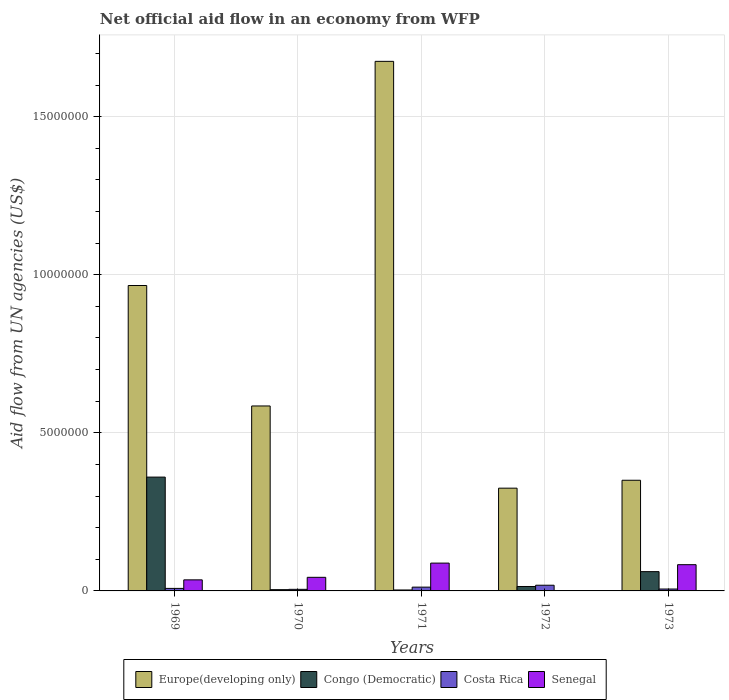Are the number of bars per tick equal to the number of legend labels?
Offer a terse response. No. Are the number of bars on each tick of the X-axis equal?
Your answer should be compact. No. How many bars are there on the 4th tick from the left?
Your answer should be compact. 3. What is the label of the 3rd group of bars from the left?
Provide a short and direct response. 1971. What is the net official aid flow in Europe(developing only) in 1973?
Keep it short and to the point. 3.50e+06. Across all years, what is the maximum net official aid flow in Senegal?
Ensure brevity in your answer.  8.80e+05. Across all years, what is the minimum net official aid flow in Senegal?
Provide a short and direct response. 0. In which year was the net official aid flow in Congo (Democratic) maximum?
Your answer should be very brief. 1969. What is the total net official aid flow in Europe(developing only) in the graph?
Offer a terse response. 3.90e+07. What is the difference between the net official aid flow in Congo (Democratic) in 1972 and that in 1973?
Your answer should be compact. -4.70e+05. What is the difference between the net official aid flow in Senegal in 1970 and the net official aid flow in Costa Rica in 1971?
Provide a short and direct response. 3.10e+05. What is the average net official aid flow in Senegal per year?
Your answer should be compact. 4.98e+05. In the year 1969, what is the difference between the net official aid flow in Senegal and net official aid flow in Congo (Democratic)?
Provide a short and direct response. -3.25e+06. In how many years, is the net official aid flow in Costa Rica greater than 16000000 US$?
Your answer should be very brief. 0. What is the ratio of the net official aid flow in Congo (Democratic) in 1969 to that in 1972?
Offer a very short reply. 25.71. Is the difference between the net official aid flow in Senegal in 1970 and 1973 greater than the difference between the net official aid flow in Congo (Democratic) in 1970 and 1973?
Keep it short and to the point. Yes. What is the difference between the highest and the second highest net official aid flow in Europe(developing only)?
Your answer should be very brief. 7.09e+06. What is the difference between the highest and the lowest net official aid flow in Congo (Democratic)?
Keep it short and to the point. 3.57e+06. Is the sum of the net official aid flow in Senegal in 1971 and 1973 greater than the maximum net official aid flow in Costa Rica across all years?
Your response must be concise. Yes. Is it the case that in every year, the sum of the net official aid flow in Europe(developing only) and net official aid flow in Congo (Democratic) is greater than the sum of net official aid flow in Senegal and net official aid flow in Costa Rica?
Your answer should be very brief. Yes. How many bars are there?
Ensure brevity in your answer.  19. Are all the bars in the graph horizontal?
Your answer should be very brief. No. How many years are there in the graph?
Make the answer very short. 5. What is the difference between two consecutive major ticks on the Y-axis?
Your response must be concise. 5.00e+06. Are the values on the major ticks of Y-axis written in scientific E-notation?
Make the answer very short. No. Does the graph contain any zero values?
Give a very brief answer. Yes. Does the graph contain grids?
Your answer should be compact. Yes. How are the legend labels stacked?
Ensure brevity in your answer.  Horizontal. What is the title of the graph?
Your response must be concise. Net official aid flow in an economy from WFP. What is the label or title of the Y-axis?
Provide a succinct answer. Aid flow from UN agencies (US$). What is the Aid flow from UN agencies (US$) of Europe(developing only) in 1969?
Give a very brief answer. 9.66e+06. What is the Aid flow from UN agencies (US$) in Congo (Democratic) in 1969?
Make the answer very short. 3.60e+06. What is the Aid flow from UN agencies (US$) of Costa Rica in 1969?
Make the answer very short. 8.00e+04. What is the Aid flow from UN agencies (US$) in Senegal in 1969?
Provide a succinct answer. 3.50e+05. What is the Aid flow from UN agencies (US$) in Europe(developing only) in 1970?
Offer a very short reply. 5.85e+06. What is the Aid flow from UN agencies (US$) in Europe(developing only) in 1971?
Ensure brevity in your answer.  1.68e+07. What is the Aid flow from UN agencies (US$) in Costa Rica in 1971?
Keep it short and to the point. 1.20e+05. What is the Aid flow from UN agencies (US$) of Senegal in 1971?
Offer a very short reply. 8.80e+05. What is the Aid flow from UN agencies (US$) in Europe(developing only) in 1972?
Your answer should be compact. 3.25e+06. What is the Aid flow from UN agencies (US$) of Congo (Democratic) in 1972?
Provide a succinct answer. 1.40e+05. What is the Aid flow from UN agencies (US$) in Senegal in 1972?
Keep it short and to the point. 0. What is the Aid flow from UN agencies (US$) in Europe(developing only) in 1973?
Ensure brevity in your answer.  3.50e+06. What is the Aid flow from UN agencies (US$) of Senegal in 1973?
Make the answer very short. 8.30e+05. Across all years, what is the maximum Aid flow from UN agencies (US$) in Europe(developing only)?
Provide a succinct answer. 1.68e+07. Across all years, what is the maximum Aid flow from UN agencies (US$) in Congo (Democratic)?
Your answer should be compact. 3.60e+06. Across all years, what is the maximum Aid flow from UN agencies (US$) of Costa Rica?
Your answer should be very brief. 1.80e+05. Across all years, what is the maximum Aid flow from UN agencies (US$) of Senegal?
Offer a very short reply. 8.80e+05. Across all years, what is the minimum Aid flow from UN agencies (US$) in Europe(developing only)?
Offer a very short reply. 3.25e+06. Across all years, what is the minimum Aid flow from UN agencies (US$) of Congo (Democratic)?
Your answer should be very brief. 3.00e+04. What is the total Aid flow from UN agencies (US$) of Europe(developing only) in the graph?
Offer a very short reply. 3.90e+07. What is the total Aid flow from UN agencies (US$) of Congo (Democratic) in the graph?
Provide a short and direct response. 4.42e+06. What is the total Aid flow from UN agencies (US$) of Senegal in the graph?
Ensure brevity in your answer.  2.49e+06. What is the difference between the Aid flow from UN agencies (US$) of Europe(developing only) in 1969 and that in 1970?
Make the answer very short. 3.81e+06. What is the difference between the Aid flow from UN agencies (US$) of Congo (Democratic) in 1969 and that in 1970?
Keep it short and to the point. 3.56e+06. What is the difference between the Aid flow from UN agencies (US$) in Costa Rica in 1969 and that in 1970?
Offer a very short reply. 3.00e+04. What is the difference between the Aid flow from UN agencies (US$) of Europe(developing only) in 1969 and that in 1971?
Your answer should be compact. -7.09e+06. What is the difference between the Aid flow from UN agencies (US$) of Congo (Democratic) in 1969 and that in 1971?
Make the answer very short. 3.57e+06. What is the difference between the Aid flow from UN agencies (US$) in Costa Rica in 1969 and that in 1971?
Your answer should be compact. -4.00e+04. What is the difference between the Aid flow from UN agencies (US$) of Senegal in 1969 and that in 1971?
Give a very brief answer. -5.30e+05. What is the difference between the Aid flow from UN agencies (US$) of Europe(developing only) in 1969 and that in 1972?
Your answer should be compact. 6.41e+06. What is the difference between the Aid flow from UN agencies (US$) in Congo (Democratic) in 1969 and that in 1972?
Offer a terse response. 3.46e+06. What is the difference between the Aid flow from UN agencies (US$) in Europe(developing only) in 1969 and that in 1973?
Offer a terse response. 6.16e+06. What is the difference between the Aid flow from UN agencies (US$) in Congo (Democratic) in 1969 and that in 1973?
Provide a short and direct response. 2.99e+06. What is the difference between the Aid flow from UN agencies (US$) in Senegal in 1969 and that in 1973?
Give a very brief answer. -4.80e+05. What is the difference between the Aid flow from UN agencies (US$) in Europe(developing only) in 1970 and that in 1971?
Provide a short and direct response. -1.09e+07. What is the difference between the Aid flow from UN agencies (US$) of Costa Rica in 1970 and that in 1971?
Make the answer very short. -7.00e+04. What is the difference between the Aid flow from UN agencies (US$) in Senegal in 1970 and that in 1971?
Offer a very short reply. -4.50e+05. What is the difference between the Aid flow from UN agencies (US$) in Europe(developing only) in 1970 and that in 1972?
Your answer should be compact. 2.60e+06. What is the difference between the Aid flow from UN agencies (US$) of Europe(developing only) in 1970 and that in 1973?
Make the answer very short. 2.35e+06. What is the difference between the Aid flow from UN agencies (US$) of Congo (Democratic) in 1970 and that in 1973?
Offer a terse response. -5.70e+05. What is the difference between the Aid flow from UN agencies (US$) in Senegal in 1970 and that in 1973?
Your answer should be compact. -4.00e+05. What is the difference between the Aid flow from UN agencies (US$) in Europe(developing only) in 1971 and that in 1972?
Offer a terse response. 1.35e+07. What is the difference between the Aid flow from UN agencies (US$) of Congo (Democratic) in 1971 and that in 1972?
Offer a very short reply. -1.10e+05. What is the difference between the Aid flow from UN agencies (US$) in Costa Rica in 1971 and that in 1972?
Ensure brevity in your answer.  -6.00e+04. What is the difference between the Aid flow from UN agencies (US$) in Europe(developing only) in 1971 and that in 1973?
Your answer should be compact. 1.32e+07. What is the difference between the Aid flow from UN agencies (US$) of Congo (Democratic) in 1971 and that in 1973?
Your response must be concise. -5.80e+05. What is the difference between the Aid flow from UN agencies (US$) in Europe(developing only) in 1972 and that in 1973?
Your answer should be compact. -2.50e+05. What is the difference between the Aid flow from UN agencies (US$) of Congo (Democratic) in 1972 and that in 1973?
Offer a terse response. -4.70e+05. What is the difference between the Aid flow from UN agencies (US$) of Europe(developing only) in 1969 and the Aid flow from UN agencies (US$) of Congo (Democratic) in 1970?
Ensure brevity in your answer.  9.62e+06. What is the difference between the Aid flow from UN agencies (US$) of Europe(developing only) in 1969 and the Aid flow from UN agencies (US$) of Costa Rica in 1970?
Ensure brevity in your answer.  9.61e+06. What is the difference between the Aid flow from UN agencies (US$) of Europe(developing only) in 1969 and the Aid flow from UN agencies (US$) of Senegal in 1970?
Keep it short and to the point. 9.23e+06. What is the difference between the Aid flow from UN agencies (US$) in Congo (Democratic) in 1969 and the Aid flow from UN agencies (US$) in Costa Rica in 1970?
Your answer should be compact. 3.55e+06. What is the difference between the Aid flow from UN agencies (US$) in Congo (Democratic) in 1969 and the Aid flow from UN agencies (US$) in Senegal in 1970?
Make the answer very short. 3.17e+06. What is the difference between the Aid flow from UN agencies (US$) in Costa Rica in 1969 and the Aid flow from UN agencies (US$) in Senegal in 1970?
Offer a terse response. -3.50e+05. What is the difference between the Aid flow from UN agencies (US$) in Europe(developing only) in 1969 and the Aid flow from UN agencies (US$) in Congo (Democratic) in 1971?
Your response must be concise. 9.63e+06. What is the difference between the Aid flow from UN agencies (US$) in Europe(developing only) in 1969 and the Aid flow from UN agencies (US$) in Costa Rica in 1971?
Offer a very short reply. 9.54e+06. What is the difference between the Aid flow from UN agencies (US$) in Europe(developing only) in 1969 and the Aid flow from UN agencies (US$) in Senegal in 1971?
Offer a terse response. 8.78e+06. What is the difference between the Aid flow from UN agencies (US$) of Congo (Democratic) in 1969 and the Aid flow from UN agencies (US$) of Costa Rica in 1971?
Ensure brevity in your answer.  3.48e+06. What is the difference between the Aid flow from UN agencies (US$) of Congo (Democratic) in 1969 and the Aid flow from UN agencies (US$) of Senegal in 1971?
Your answer should be very brief. 2.72e+06. What is the difference between the Aid flow from UN agencies (US$) in Costa Rica in 1969 and the Aid flow from UN agencies (US$) in Senegal in 1971?
Your answer should be compact. -8.00e+05. What is the difference between the Aid flow from UN agencies (US$) of Europe(developing only) in 1969 and the Aid flow from UN agencies (US$) of Congo (Democratic) in 1972?
Give a very brief answer. 9.52e+06. What is the difference between the Aid flow from UN agencies (US$) of Europe(developing only) in 1969 and the Aid flow from UN agencies (US$) of Costa Rica in 1972?
Make the answer very short. 9.48e+06. What is the difference between the Aid flow from UN agencies (US$) of Congo (Democratic) in 1969 and the Aid flow from UN agencies (US$) of Costa Rica in 1972?
Make the answer very short. 3.42e+06. What is the difference between the Aid flow from UN agencies (US$) of Europe(developing only) in 1969 and the Aid flow from UN agencies (US$) of Congo (Democratic) in 1973?
Ensure brevity in your answer.  9.05e+06. What is the difference between the Aid flow from UN agencies (US$) in Europe(developing only) in 1969 and the Aid flow from UN agencies (US$) in Costa Rica in 1973?
Your response must be concise. 9.60e+06. What is the difference between the Aid flow from UN agencies (US$) in Europe(developing only) in 1969 and the Aid flow from UN agencies (US$) in Senegal in 1973?
Your response must be concise. 8.83e+06. What is the difference between the Aid flow from UN agencies (US$) of Congo (Democratic) in 1969 and the Aid flow from UN agencies (US$) of Costa Rica in 1973?
Provide a short and direct response. 3.54e+06. What is the difference between the Aid flow from UN agencies (US$) of Congo (Democratic) in 1969 and the Aid flow from UN agencies (US$) of Senegal in 1973?
Provide a succinct answer. 2.77e+06. What is the difference between the Aid flow from UN agencies (US$) in Costa Rica in 1969 and the Aid flow from UN agencies (US$) in Senegal in 1973?
Your response must be concise. -7.50e+05. What is the difference between the Aid flow from UN agencies (US$) in Europe(developing only) in 1970 and the Aid flow from UN agencies (US$) in Congo (Democratic) in 1971?
Provide a short and direct response. 5.82e+06. What is the difference between the Aid flow from UN agencies (US$) of Europe(developing only) in 1970 and the Aid flow from UN agencies (US$) of Costa Rica in 1971?
Your answer should be very brief. 5.73e+06. What is the difference between the Aid flow from UN agencies (US$) of Europe(developing only) in 1970 and the Aid flow from UN agencies (US$) of Senegal in 1971?
Your response must be concise. 4.97e+06. What is the difference between the Aid flow from UN agencies (US$) in Congo (Democratic) in 1970 and the Aid flow from UN agencies (US$) in Costa Rica in 1971?
Your answer should be very brief. -8.00e+04. What is the difference between the Aid flow from UN agencies (US$) in Congo (Democratic) in 1970 and the Aid flow from UN agencies (US$) in Senegal in 1971?
Your answer should be very brief. -8.40e+05. What is the difference between the Aid flow from UN agencies (US$) in Costa Rica in 1970 and the Aid flow from UN agencies (US$) in Senegal in 1971?
Your response must be concise. -8.30e+05. What is the difference between the Aid flow from UN agencies (US$) in Europe(developing only) in 1970 and the Aid flow from UN agencies (US$) in Congo (Democratic) in 1972?
Ensure brevity in your answer.  5.71e+06. What is the difference between the Aid flow from UN agencies (US$) in Europe(developing only) in 1970 and the Aid flow from UN agencies (US$) in Costa Rica in 1972?
Your answer should be compact. 5.67e+06. What is the difference between the Aid flow from UN agencies (US$) in Congo (Democratic) in 1970 and the Aid flow from UN agencies (US$) in Costa Rica in 1972?
Offer a very short reply. -1.40e+05. What is the difference between the Aid flow from UN agencies (US$) of Europe(developing only) in 1970 and the Aid flow from UN agencies (US$) of Congo (Democratic) in 1973?
Offer a terse response. 5.24e+06. What is the difference between the Aid flow from UN agencies (US$) in Europe(developing only) in 1970 and the Aid flow from UN agencies (US$) in Costa Rica in 1973?
Give a very brief answer. 5.79e+06. What is the difference between the Aid flow from UN agencies (US$) of Europe(developing only) in 1970 and the Aid flow from UN agencies (US$) of Senegal in 1973?
Keep it short and to the point. 5.02e+06. What is the difference between the Aid flow from UN agencies (US$) in Congo (Democratic) in 1970 and the Aid flow from UN agencies (US$) in Costa Rica in 1973?
Ensure brevity in your answer.  -2.00e+04. What is the difference between the Aid flow from UN agencies (US$) of Congo (Democratic) in 1970 and the Aid flow from UN agencies (US$) of Senegal in 1973?
Your answer should be very brief. -7.90e+05. What is the difference between the Aid flow from UN agencies (US$) of Costa Rica in 1970 and the Aid flow from UN agencies (US$) of Senegal in 1973?
Ensure brevity in your answer.  -7.80e+05. What is the difference between the Aid flow from UN agencies (US$) of Europe(developing only) in 1971 and the Aid flow from UN agencies (US$) of Congo (Democratic) in 1972?
Make the answer very short. 1.66e+07. What is the difference between the Aid flow from UN agencies (US$) in Europe(developing only) in 1971 and the Aid flow from UN agencies (US$) in Costa Rica in 1972?
Make the answer very short. 1.66e+07. What is the difference between the Aid flow from UN agencies (US$) in Congo (Democratic) in 1971 and the Aid flow from UN agencies (US$) in Costa Rica in 1972?
Your answer should be compact. -1.50e+05. What is the difference between the Aid flow from UN agencies (US$) of Europe(developing only) in 1971 and the Aid flow from UN agencies (US$) of Congo (Democratic) in 1973?
Make the answer very short. 1.61e+07. What is the difference between the Aid flow from UN agencies (US$) in Europe(developing only) in 1971 and the Aid flow from UN agencies (US$) in Costa Rica in 1973?
Make the answer very short. 1.67e+07. What is the difference between the Aid flow from UN agencies (US$) in Europe(developing only) in 1971 and the Aid flow from UN agencies (US$) in Senegal in 1973?
Ensure brevity in your answer.  1.59e+07. What is the difference between the Aid flow from UN agencies (US$) of Congo (Democratic) in 1971 and the Aid flow from UN agencies (US$) of Senegal in 1973?
Make the answer very short. -8.00e+05. What is the difference between the Aid flow from UN agencies (US$) of Costa Rica in 1971 and the Aid flow from UN agencies (US$) of Senegal in 1973?
Provide a succinct answer. -7.10e+05. What is the difference between the Aid flow from UN agencies (US$) in Europe(developing only) in 1972 and the Aid flow from UN agencies (US$) in Congo (Democratic) in 1973?
Ensure brevity in your answer.  2.64e+06. What is the difference between the Aid flow from UN agencies (US$) of Europe(developing only) in 1972 and the Aid flow from UN agencies (US$) of Costa Rica in 1973?
Offer a terse response. 3.19e+06. What is the difference between the Aid flow from UN agencies (US$) of Europe(developing only) in 1972 and the Aid flow from UN agencies (US$) of Senegal in 1973?
Provide a short and direct response. 2.42e+06. What is the difference between the Aid flow from UN agencies (US$) of Congo (Democratic) in 1972 and the Aid flow from UN agencies (US$) of Costa Rica in 1973?
Give a very brief answer. 8.00e+04. What is the difference between the Aid flow from UN agencies (US$) of Congo (Democratic) in 1972 and the Aid flow from UN agencies (US$) of Senegal in 1973?
Provide a succinct answer. -6.90e+05. What is the difference between the Aid flow from UN agencies (US$) of Costa Rica in 1972 and the Aid flow from UN agencies (US$) of Senegal in 1973?
Offer a very short reply. -6.50e+05. What is the average Aid flow from UN agencies (US$) in Europe(developing only) per year?
Provide a succinct answer. 7.80e+06. What is the average Aid flow from UN agencies (US$) in Congo (Democratic) per year?
Provide a short and direct response. 8.84e+05. What is the average Aid flow from UN agencies (US$) in Costa Rica per year?
Give a very brief answer. 9.80e+04. What is the average Aid flow from UN agencies (US$) in Senegal per year?
Your answer should be compact. 4.98e+05. In the year 1969, what is the difference between the Aid flow from UN agencies (US$) in Europe(developing only) and Aid flow from UN agencies (US$) in Congo (Democratic)?
Your answer should be very brief. 6.06e+06. In the year 1969, what is the difference between the Aid flow from UN agencies (US$) of Europe(developing only) and Aid flow from UN agencies (US$) of Costa Rica?
Ensure brevity in your answer.  9.58e+06. In the year 1969, what is the difference between the Aid flow from UN agencies (US$) in Europe(developing only) and Aid flow from UN agencies (US$) in Senegal?
Give a very brief answer. 9.31e+06. In the year 1969, what is the difference between the Aid flow from UN agencies (US$) in Congo (Democratic) and Aid flow from UN agencies (US$) in Costa Rica?
Offer a very short reply. 3.52e+06. In the year 1969, what is the difference between the Aid flow from UN agencies (US$) in Congo (Democratic) and Aid flow from UN agencies (US$) in Senegal?
Offer a very short reply. 3.25e+06. In the year 1970, what is the difference between the Aid flow from UN agencies (US$) of Europe(developing only) and Aid flow from UN agencies (US$) of Congo (Democratic)?
Provide a succinct answer. 5.81e+06. In the year 1970, what is the difference between the Aid flow from UN agencies (US$) in Europe(developing only) and Aid flow from UN agencies (US$) in Costa Rica?
Your answer should be very brief. 5.80e+06. In the year 1970, what is the difference between the Aid flow from UN agencies (US$) in Europe(developing only) and Aid flow from UN agencies (US$) in Senegal?
Provide a succinct answer. 5.42e+06. In the year 1970, what is the difference between the Aid flow from UN agencies (US$) in Congo (Democratic) and Aid flow from UN agencies (US$) in Senegal?
Your answer should be very brief. -3.90e+05. In the year 1970, what is the difference between the Aid flow from UN agencies (US$) of Costa Rica and Aid flow from UN agencies (US$) of Senegal?
Make the answer very short. -3.80e+05. In the year 1971, what is the difference between the Aid flow from UN agencies (US$) in Europe(developing only) and Aid flow from UN agencies (US$) in Congo (Democratic)?
Make the answer very short. 1.67e+07. In the year 1971, what is the difference between the Aid flow from UN agencies (US$) of Europe(developing only) and Aid flow from UN agencies (US$) of Costa Rica?
Make the answer very short. 1.66e+07. In the year 1971, what is the difference between the Aid flow from UN agencies (US$) of Europe(developing only) and Aid flow from UN agencies (US$) of Senegal?
Offer a very short reply. 1.59e+07. In the year 1971, what is the difference between the Aid flow from UN agencies (US$) in Congo (Democratic) and Aid flow from UN agencies (US$) in Costa Rica?
Offer a very short reply. -9.00e+04. In the year 1971, what is the difference between the Aid flow from UN agencies (US$) of Congo (Democratic) and Aid flow from UN agencies (US$) of Senegal?
Offer a terse response. -8.50e+05. In the year 1971, what is the difference between the Aid flow from UN agencies (US$) in Costa Rica and Aid flow from UN agencies (US$) in Senegal?
Provide a succinct answer. -7.60e+05. In the year 1972, what is the difference between the Aid flow from UN agencies (US$) of Europe(developing only) and Aid flow from UN agencies (US$) of Congo (Democratic)?
Offer a terse response. 3.11e+06. In the year 1972, what is the difference between the Aid flow from UN agencies (US$) in Europe(developing only) and Aid flow from UN agencies (US$) in Costa Rica?
Your answer should be compact. 3.07e+06. In the year 1972, what is the difference between the Aid flow from UN agencies (US$) of Congo (Democratic) and Aid flow from UN agencies (US$) of Costa Rica?
Your answer should be compact. -4.00e+04. In the year 1973, what is the difference between the Aid flow from UN agencies (US$) of Europe(developing only) and Aid flow from UN agencies (US$) of Congo (Democratic)?
Offer a terse response. 2.89e+06. In the year 1973, what is the difference between the Aid flow from UN agencies (US$) of Europe(developing only) and Aid flow from UN agencies (US$) of Costa Rica?
Provide a succinct answer. 3.44e+06. In the year 1973, what is the difference between the Aid flow from UN agencies (US$) in Europe(developing only) and Aid flow from UN agencies (US$) in Senegal?
Give a very brief answer. 2.67e+06. In the year 1973, what is the difference between the Aid flow from UN agencies (US$) of Congo (Democratic) and Aid flow from UN agencies (US$) of Costa Rica?
Your response must be concise. 5.50e+05. In the year 1973, what is the difference between the Aid flow from UN agencies (US$) in Congo (Democratic) and Aid flow from UN agencies (US$) in Senegal?
Your answer should be compact. -2.20e+05. In the year 1973, what is the difference between the Aid flow from UN agencies (US$) of Costa Rica and Aid flow from UN agencies (US$) of Senegal?
Give a very brief answer. -7.70e+05. What is the ratio of the Aid flow from UN agencies (US$) of Europe(developing only) in 1969 to that in 1970?
Make the answer very short. 1.65. What is the ratio of the Aid flow from UN agencies (US$) of Costa Rica in 1969 to that in 1970?
Your answer should be very brief. 1.6. What is the ratio of the Aid flow from UN agencies (US$) of Senegal in 1969 to that in 1970?
Make the answer very short. 0.81. What is the ratio of the Aid flow from UN agencies (US$) in Europe(developing only) in 1969 to that in 1971?
Keep it short and to the point. 0.58. What is the ratio of the Aid flow from UN agencies (US$) of Congo (Democratic) in 1969 to that in 1971?
Offer a very short reply. 120. What is the ratio of the Aid flow from UN agencies (US$) in Costa Rica in 1969 to that in 1971?
Keep it short and to the point. 0.67. What is the ratio of the Aid flow from UN agencies (US$) in Senegal in 1969 to that in 1971?
Your answer should be compact. 0.4. What is the ratio of the Aid flow from UN agencies (US$) in Europe(developing only) in 1969 to that in 1972?
Make the answer very short. 2.97. What is the ratio of the Aid flow from UN agencies (US$) in Congo (Democratic) in 1969 to that in 1972?
Offer a terse response. 25.71. What is the ratio of the Aid flow from UN agencies (US$) in Costa Rica in 1969 to that in 1972?
Make the answer very short. 0.44. What is the ratio of the Aid flow from UN agencies (US$) in Europe(developing only) in 1969 to that in 1973?
Keep it short and to the point. 2.76. What is the ratio of the Aid flow from UN agencies (US$) in Congo (Democratic) in 1969 to that in 1973?
Your response must be concise. 5.9. What is the ratio of the Aid flow from UN agencies (US$) in Senegal in 1969 to that in 1973?
Your answer should be compact. 0.42. What is the ratio of the Aid flow from UN agencies (US$) in Europe(developing only) in 1970 to that in 1971?
Keep it short and to the point. 0.35. What is the ratio of the Aid flow from UN agencies (US$) in Congo (Democratic) in 1970 to that in 1971?
Offer a very short reply. 1.33. What is the ratio of the Aid flow from UN agencies (US$) of Costa Rica in 1970 to that in 1971?
Make the answer very short. 0.42. What is the ratio of the Aid flow from UN agencies (US$) in Senegal in 1970 to that in 1971?
Give a very brief answer. 0.49. What is the ratio of the Aid flow from UN agencies (US$) of Europe(developing only) in 1970 to that in 1972?
Offer a terse response. 1.8. What is the ratio of the Aid flow from UN agencies (US$) in Congo (Democratic) in 1970 to that in 1972?
Give a very brief answer. 0.29. What is the ratio of the Aid flow from UN agencies (US$) in Costa Rica in 1970 to that in 1972?
Keep it short and to the point. 0.28. What is the ratio of the Aid flow from UN agencies (US$) of Europe(developing only) in 1970 to that in 1973?
Give a very brief answer. 1.67. What is the ratio of the Aid flow from UN agencies (US$) in Congo (Democratic) in 1970 to that in 1973?
Your answer should be very brief. 0.07. What is the ratio of the Aid flow from UN agencies (US$) in Costa Rica in 1970 to that in 1973?
Offer a very short reply. 0.83. What is the ratio of the Aid flow from UN agencies (US$) in Senegal in 1970 to that in 1973?
Give a very brief answer. 0.52. What is the ratio of the Aid flow from UN agencies (US$) in Europe(developing only) in 1971 to that in 1972?
Give a very brief answer. 5.15. What is the ratio of the Aid flow from UN agencies (US$) of Congo (Democratic) in 1971 to that in 1972?
Provide a short and direct response. 0.21. What is the ratio of the Aid flow from UN agencies (US$) in Costa Rica in 1971 to that in 1972?
Your response must be concise. 0.67. What is the ratio of the Aid flow from UN agencies (US$) in Europe(developing only) in 1971 to that in 1973?
Your answer should be very brief. 4.79. What is the ratio of the Aid flow from UN agencies (US$) of Congo (Democratic) in 1971 to that in 1973?
Your response must be concise. 0.05. What is the ratio of the Aid flow from UN agencies (US$) in Senegal in 1971 to that in 1973?
Make the answer very short. 1.06. What is the ratio of the Aid flow from UN agencies (US$) in Europe(developing only) in 1972 to that in 1973?
Your response must be concise. 0.93. What is the ratio of the Aid flow from UN agencies (US$) of Congo (Democratic) in 1972 to that in 1973?
Provide a short and direct response. 0.23. What is the ratio of the Aid flow from UN agencies (US$) of Costa Rica in 1972 to that in 1973?
Your answer should be very brief. 3. What is the difference between the highest and the second highest Aid flow from UN agencies (US$) of Europe(developing only)?
Provide a succinct answer. 7.09e+06. What is the difference between the highest and the second highest Aid flow from UN agencies (US$) of Congo (Democratic)?
Offer a terse response. 2.99e+06. What is the difference between the highest and the lowest Aid flow from UN agencies (US$) in Europe(developing only)?
Ensure brevity in your answer.  1.35e+07. What is the difference between the highest and the lowest Aid flow from UN agencies (US$) of Congo (Democratic)?
Make the answer very short. 3.57e+06. What is the difference between the highest and the lowest Aid flow from UN agencies (US$) of Costa Rica?
Provide a short and direct response. 1.30e+05. What is the difference between the highest and the lowest Aid flow from UN agencies (US$) in Senegal?
Offer a very short reply. 8.80e+05. 